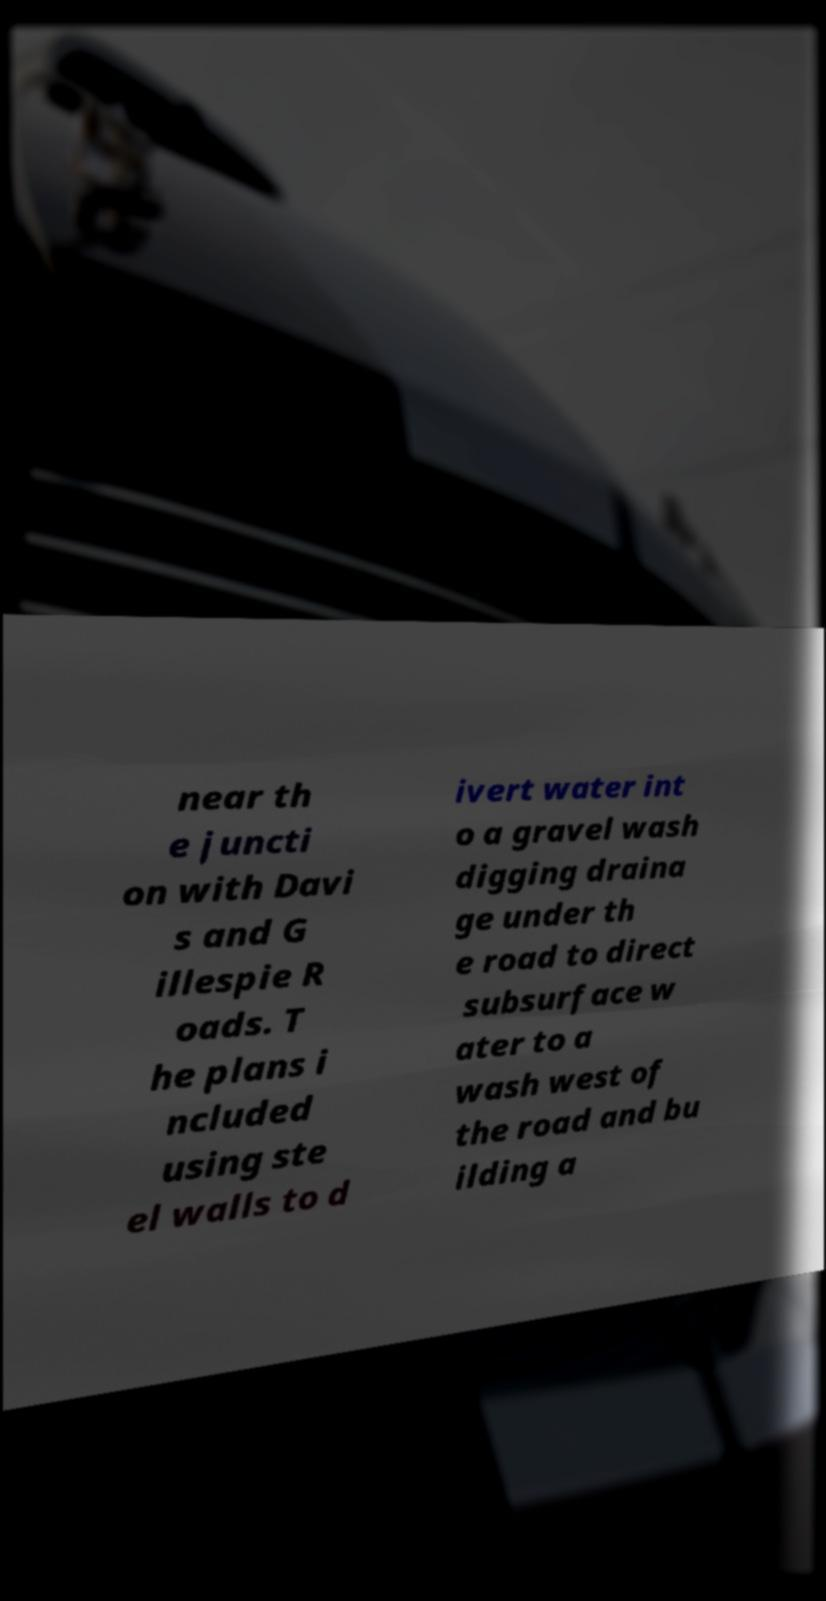Could you assist in decoding the text presented in this image and type it out clearly? near th e juncti on with Davi s and G illespie R oads. T he plans i ncluded using ste el walls to d ivert water int o a gravel wash digging draina ge under th e road to direct subsurface w ater to a wash west of the road and bu ilding a 